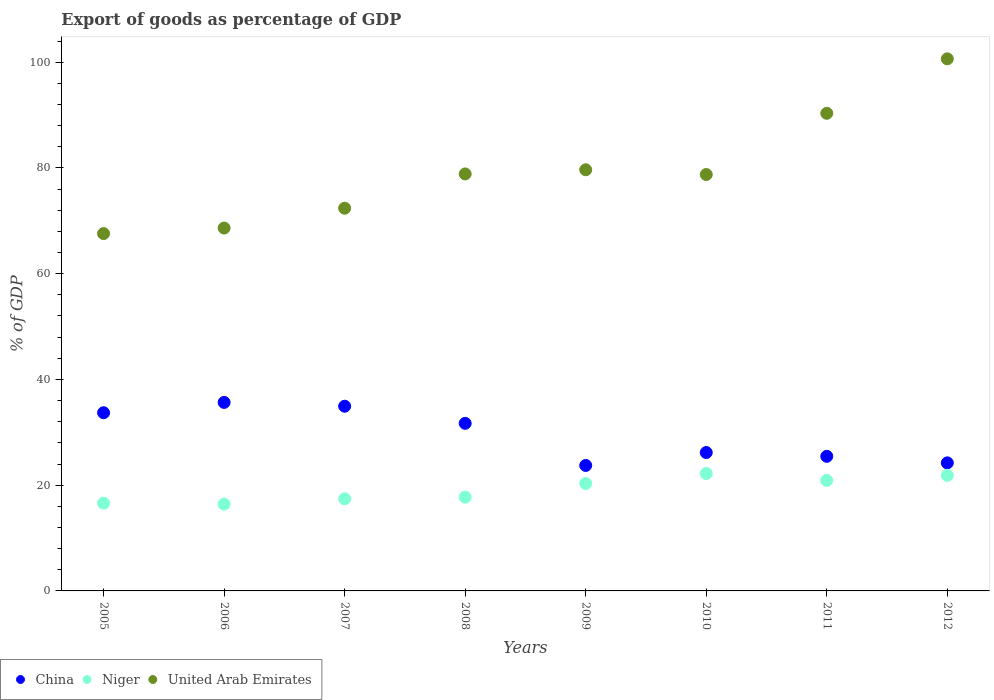What is the export of goods as percentage of GDP in United Arab Emirates in 2008?
Keep it short and to the point. 78.87. Across all years, what is the maximum export of goods as percentage of GDP in United Arab Emirates?
Make the answer very short. 100.63. Across all years, what is the minimum export of goods as percentage of GDP in China?
Make the answer very short. 23.73. What is the total export of goods as percentage of GDP in China in the graph?
Give a very brief answer. 235.56. What is the difference between the export of goods as percentage of GDP in China in 2005 and that in 2009?
Provide a short and direct response. 9.97. What is the difference between the export of goods as percentage of GDP in United Arab Emirates in 2005 and the export of goods as percentage of GDP in Niger in 2008?
Provide a short and direct response. 49.86. What is the average export of goods as percentage of GDP in United Arab Emirates per year?
Offer a very short reply. 79.61. In the year 2005, what is the difference between the export of goods as percentage of GDP in United Arab Emirates and export of goods as percentage of GDP in Niger?
Provide a succinct answer. 50.99. What is the ratio of the export of goods as percentage of GDP in United Arab Emirates in 2007 to that in 2010?
Give a very brief answer. 0.92. Is the export of goods as percentage of GDP in United Arab Emirates in 2007 less than that in 2008?
Your answer should be very brief. Yes. What is the difference between the highest and the second highest export of goods as percentage of GDP in United Arab Emirates?
Make the answer very short. 10.3. What is the difference between the highest and the lowest export of goods as percentage of GDP in United Arab Emirates?
Your response must be concise. 33.05. Is it the case that in every year, the sum of the export of goods as percentage of GDP in Niger and export of goods as percentage of GDP in China  is greater than the export of goods as percentage of GDP in United Arab Emirates?
Ensure brevity in your answer.  No. Does the export of goods as percentage of GDP in China monotonically increase over the years?
Give a very brief answer. No. How many years are there in the graph?
Provide a short and direct response. 8. Are the values on the major ticks of Y-axis written in scientific E-notation?
Give a very brief answer. No. Does the graph contain any zero values?
Provide a succinct answer. No. Does the graph contain grids?
Give a very brief answer. No. Where does the legend appear in the graph?
Provide a short and direct response. Bottom left. How are the legend labels stacked?
Your response must be concise. Horizontal. What is the title of the graph?
Ensure brevity in your answer.  Export of goods as percentage of GDP. Does "Congo (Democratic)" appear as one of the legend labels in the graph?
Offer a terse response. No. What is the label or title of the Y-axis?
Ensure brevity in your answer.  % of GDP. What is the % of GDP in China in 2005?
Provide a succinct answer. 33.7. What is the % of GDP in Niger in 2005?
Offer a very short reply. 16.6. What is the % of GDP of United Arab Emirates in 2005?
Provide a short and direct response. 67.59. What is the % of GDP of China in 2006?
Your answer should be compact. 35.65. What is the % of GDP of Niger in 2006?
Your answer should be very brief. 16.41. What is the % of GDP of United Arab Emirates in 2006?
Keep it short and to the point. 68.63. What is the % of GDP of China in 2007?
Ensure brevity in your answer.  34.93. What is the % of GDP of Niger in 2007?
Offer a very short reply. 17.43. What is the % of GDP in United Arab Emirates in 2007?
Keep it short and to the point. 72.38. What is the % of GDP in China in 2008?
Keep it short and to the point. 31.7. What is the % of GDP in Niger in 2008?
Give a very brief answer. 17.73. What is the % of GDP in United Arab Emirates in 2008?
Give a very brief answer. 78.87. What is the % of GDP of China in 2009?
Make the answer very short. 23.73. What is the % of GDP of Niger in 2009?
Ensure brevity in your answer.  20.32. What is the % of GDP of United Arab Emirates in 2009?
Offer a terse response. 79.65. What is the % of GDP of China in 2010?
Offer a terse response. 26.17. What is the % of GDP in Niger in 2010?
Make the answer very short. 22.2. What is the % of GDP in United Arab Emirates in 2010?
Offer a very short reply. 78.75. What is the % of GDP in China in 2011?
Offer a very short reply. 25.46. What is the % of GDP in Niger in 2011?
Give a very brief answer. 20.9. What is the % of GDP of United Arab Emirates in 2011?
Make the answer very short. 90.33. What is the % of GDP of China in 2012?
Make the answer very short. 24.22. What is the % of GDP of Niger in 2012?
Keep it short and to the point. 21.86. What is the % of GDP of United Arab Emirates in 2012?
Make the answer very short. 100.63. Across all years, what is the maximum % of GDP of China?
Your answer should be very brief. 35.65. Across all years, what is the maximum % of GDP of Niger?
Your response must be concise. 22.2. Across all years, what is the maximum % of GDP of United Arab Emirates?
Provide a short and direct response. 100.63. Across all years, what is the minimum % of GDP in China?
Ensure brevity in your answer.  23.73. Across all years, what is the minimum % of GDP in Niger?
Your answer should be compact. 16.41. Across all years, what is the minimum % of GDP of United Arab Emirates?
Offer a terse response. 67.59. What is the total % of GDP of China in the graph?
Your response must be concise. 235.56. What is the total % of GDP of Niger in the graph?
Offer a terse response. 153.45. What is the total % of GDP in United Arab Emirates in the graph?
Provide a succinct answer. 636.84. What is the difference between the % of GDP of China in 2005 and that in 2006?
Keep it short and to the point. -1.95. What is the difference between the % of GDP of Niger in 2005 and that in 2006?
Provide a short and direct response. 0.18. What is the difference between the % of GDP in United Arab Emirates in 2005 and that in 2006?
Provide a short and direct response. -1.05. What is the difference between the % of GDP in China in 2005 and that in 2007?
Provide a short and direct response. -1.23. What is the difference between the % of GDP in Niger in 2005 and that in 2007?
Your response must be concise. -0.83. What is the difference between the % of GDP in United Arab Emirates in 2005 and that in 2007?
Your answer should be compact. -4.8. What is the difference between the % of GDP of China in 2005 and that in 2008?
Offer a very short reply. 2.01. What is the difference between the % of GDP in Niger in 2005 and that in 2008?
Provide a short and direct response. -1.13. What is the difference between the % of GDP of United Arab Emirates in 2005 and that in 2008?
Give a very brief answer. -11.28. What is the difference between the % of GDP of China in 2005 and that in 2009?
Your answer should be very brief. 9.97. What is the difference between the % of GDP of Niger in 2005 and that in 2009?
Provide a succinct answer. -3.73. What is the difference between the % of GDP in United Arab Emirates in 2005 and that in 2009?
Make the answer very short. -12.07. What is the difference between the % of GDP of China in 2005 and that in 2010?
Offer a very short reply. 7.53. What is the difference between the % of GDP in Niger in 2005 and that in 2010?
Provide a succinct answer. -5.6. What is the difference between the % of GDP in United Arab Emirates in 2005 and that in 2010?
Your answer should be compact. -11.17. What is the difference between the % of GDP in China in 2005 and that in 2011?
Your answer should be very brief. 8.24. What is the difference between the % of GDP in Niger in 2005 and that in 2011?
Provide a short and direct response. -4.31. What is the difference between the % of GDP of United Arab Emirates in 2005 and that in 2011?
Offer a very short reply. -22.75. What is the difference between the % of GDP of China in 2005 and that in 2012?
Give a very brief answer. 9.48. What is the difference between the % of GDP of Niger in 2005 and that in 2012?
Ensure brevity in your answer.  -5.26. What is the difference between the % of GDP of United Arab Emirates in 2005 and that in 2012?
Provide a succinct answer. -33.05. What is the difference between the % of GDP of China in 2006 and that in 2007?
Your answer should be compact. 0.72. What is the difference between the % of GDP of Niger in 2006 and that in 2007?
Your answer should be very brief. -1.02. What is the difference between the % of GDP in United Arab Emirates in 2006 and that in 2007?
Ensure brevity in your answer.  -3.75. What is the difference between the % of GDP of China in 2006 and that in 2008?
Give a very brief answer. 3.96. What is the difference between the % of GDP of Niger in 2006 and that in 2008?
Make the answer very short. -1.32. What is the difference between the % of GDP in United Arab Emirates in 2006 and that in 2008?
Offer a very short reply. -10.24. What is the difference between the % of GDP of China in 2006 and that in 2009?
Offer a terse response. 11.92. What is the difference between the % of GDP in Niger in 2006 and that in 2009?
Provide a succinct answer. -3.91. What is the difference between the % of GDP of United Arab Emirates in 2006 and that in 2009?
Your response must be concise. -11.02. What is the difference between the % of GDP in China in 2006 and that in 2010?
Offer a very short reply. 9.48. What is the difference between the % of GDP of Niger in 2006 and that in 2010?
Ensure brevity in your answer.  -5.79. What is the difference between the % of GDP in United Arab Emirates in 2006 and that in 2010?
Provide a short and direct response. -10.12. What is the difference between the % of GDP in China in 2006 and that in 2011?
Your response must be concise. 10.2. What is the difference between the % of GDP in Niger in 2006 and that in 2011?
Your response must be concise. -4.49. What is the difference between the % of GDP of United Arab Emirates in 2006 and that in 2011?
Give a very brief answer. -21.7. What is the difference between the % of GDP in China in 2006 and that in 2012?
Keep it short and to the point. 11.43. What is the difference between the % of GDP in Niger in 2006 and that in 2012?
Provide a succinct answer. -5.45. What is the difference between the % of GDP in United Arab Emirates in 2006 and that in 2012?
Your response must be concise. -32. What is the difference between the % of GDP of China in 2007 and that in 2008?
Your response must be concise. 3.24. What is the difference between the % of GDP of Niger in 2007 and that in 2008?
Your answer should be very brief. -0.3. What is the difference between the % of GDP of United Arab Emirates in 2007 and that in 2008?
Offer a very short reply. -6.48. What is the difference between the % of GDP in China in 2007 and that in 2009?
Make the answer very short. 11.2. What is the difference between the % of GDP in Niger in 2007 and that in 2009?
Your response must be concise. -2.89. What is the difference between the % of GDP in United Arab Emirates in 2007 and that in 2009?
Your response must be concise. -7.27. What is the difference between the % of GDP in China in 2007 and that in 2010?
Make the answer very short. 8.76. What is the difference between the % of GDP of Niger in 2007 and that in 2010?
Your answer should be compact. -4.77. What is the difference between the % of GDP of United Arab Emirates in 2007 and that in 2010?
Provide a succinct answer. -6.37. What is the difference between the % of GDP in China in 2007 and that in 2011?
Keep it short and to the point. 9.48. What is the difference between the % of GDP of Niger in 2007 and that in 2011?
Keep it short and to the point. -3.47. What is the difference between the % of GDP of United Arab Emirates in 2007 and that in 2011?
Provide a succinct answer. -17.95. What is the difference between the % of GDP of China in 2007 and that in 2012?
Your answer should be compact. 10.71. What is the difference between the % of GDP in Niger in 2007 and that in 2012?
Your response must be concise. -4.43. What is the difference between the % of GDP in United Arab Emirates in 2007 and that in 2012?
Provide a succinct answer. -28.25. What is the difference between the % of GDP in China in 2008 and that in 2009?
Provide a short and direct response. 7.96. What is the difference between the % of GDP in Niger in 2008 and that in 2009?
Provide a short and direct response. -2.59. What is the difference between the % of GDP of United Arab Emirates in 2008 and that in 2009?
Your response must be concise. -0.79. What is the difference between the % of GDP in China in 2008 and that in 2010?
Keep it short and to the point. 5.52. What is the difference between the % of GDP of Niger in 2008 and that in 2010?
Offer a very short reply. -4.47. What is the difference between the % of GDP in United Arab Emirates in 2008 and that in 2010?
Your answer should be very brief. 0.11. What is the difference between the % of GDP in China in 2008 and that in 2011?
Your response must be concise. 6.24. What is the difference between the % of GDP in Niger in 2008 and that in 2011?
Keep it short and to the point. -3.17. What is the difference between the % of GDP of United Arab Emirates in 2008 and that in 2011?
Offer a terse response. -11.47. What is the difference between the % of GDP in China in 2008 and that in 2012?
Give a very brief answer. 7.48. What is the difference between the % of GDP of Niger in 2008 and that in 2012?
Your response must be concise. -4.13. What is the difference between the % of GDP of United Arab Emirates in 2008 and that in 2012?
Ensure brevity in your answer.  -21.77. What is the difference between the % of GDP in China in 2009 and that in 2010?
Your response must be concise. -2.44. What is the difference between the % of GDP of Niger in 2009 and that in 2010?
Give a very brief answer. -1.88. What is the difference between the % of GDP in United Arab Emirates in 2009 and that in 2010?
Give a very brief answer. 0.9. What is the difference between the % of GDP in China in 2009 and that in 2011?
Provide a short and direct response. -1.72. What is the difference between the % of GDP of Niger in 2009 and that in 2011?
Ensure brevity in your answer.  -0.58. What is the difference between the % of GDP of United Arab Emirates in 2009 and that in 2011?
Make the answer very short. -10.68. What is the difference between the % of GDP in China in 2009 and that in 2012?
Keep it short and to the point. -0.49. What is the difference between the % of GDP of Niger in 2009 and that in 2012?
Provide a short and direct response. -1.54. What is the difference between the % of GDP of United Arab Emirates in 2009 and that in 2012?
Your response must be concise. -20.98. What is the difference between the % of GDP in China in 2010 and that in 2011?
Provide a short and direct response. 0.72. What is the difference between the % of GDP in Niger in 2010 and that in 2011?
Provide a short and direct response. 1.3. What is the difference between the % of GDP of United Arab Emirates in 2010 and that in 2011?
Keep it short and to the point. -11.58. What is the difference between the % of GDP in China in 2010 and that in 2012?
Offer a terse response. 1.95. What is the difference between the % of GDP in Niger in 2010 and that in 2012?
Your answer should be compact. 0.34. What is the difference between the % of GDP in United Arab Emirates in 2010 and that in 2012?
Make the answer very short. -21.88. What is the difference between the % of GDP in China in 2011 and that in 2012?
Your response must be concise. 1.24. What is the difference between the % of GDP in Niger in 2011 and that in 2012?
Your response must be concise. -0.96. What is the difference between the % of GDP of United Arab Emirates in 2011 and that in 2012?
Offer a very short reply. -10.3. What is the difference between the % of GDP in China in 2005 and the % of GDP in Niger in 2006?
Keep it short and to the point. 17.29. What is the difference between the % of GDP in China in 2005 and the % of GDP in United Arab Emirates in 2006?
Provide a succinct answer. -34.93. What is the difference between the % of GDP of Niger in 2005 and the % of GDP of United Arab Emirates in 2006?
Provide a succinct answer. -52.04. What is the difference between the % of GDP of China in 2005 and the % of GDP of Niger in 2007?
Provide a short and direct response. 16.27. What is the difference between the % of GDP of China in 2005 and the % of GDP of United Arab Emirates in 2007?
Your response must be concise. -38.68. What is the difference between the % of GDP in Niger in 2005 and the % of GDP in United Arab Emirates in 2007?
Your response must be concise. -55.79. What is the difference between the % of GDP of China in 2005 and the % of GDP of Niger in 2008?
Provide a succinct answer. 15.97. What is the difference between the % of GDP in China in 2005 and the % of GDP in United Arab Emirates in 2008?
Provide a succinct answer. -45.17. What is the difference between the % of GDP of Niger in 2005 and the % of GDP of United Arab Emirates in 2008?
Keep it short and to the point. -62.27. What is the difference between the % of GDP of China in 2005 and the % of GDP of Niger in 2009?
Your answer should be compact. 13.38. What is the difference between the % of GDP of China in 2005 and the % of GDP of United Arab Emirates in 2009?
Keep it short and to the point. -45.95. What is the difference between the % of GDP in Niger in 2005 and the % of GDP in United Arab Emirates in 2009?
Offer a very short reply. -63.06. What is the difference between the % of GDP of China in 2005 and the % of GDP of Niger in 2010?
Provide a succinct answer. 11.5. What is the difference between the % of GDP of China in 2005 and the % of GDP of United Arab Emirates in 2010?
Offer a terse response. -45.05. What is the difference between the % of GDP in Niger in 2005 and the % of GDP in United Arab Emirates in 2010?
Your answer should be compact. -62.16. What is the difference between the % of GDP in China in 2005 and the % of GDP in Niger in 2011?
Give a very brief answer. 12.8. What is the difference between the % of GDP of China in 2005 and the % of GDP of United Arab Emirates in 2011?
Keep it short and to the point. -56.63. What is the difference between the % of GDP in Niger in 2005 and the % of GDP in United Arab Emirates in 2011?
Provide a succinct answer. -73.74. What is the difference between the % of GDP of China in 2005 and the % of GDP of Niger in 2012?
Offer a terse response. 11.84. What is the difference between the % of GDP in China in 2005 and the % of GDP in United Arab Emirates in 2012?
Offer a terse response. -66.93. What is the difference between the % of GDP of Niger in 2005 and the % of GDP of United Arab Emirates in 2012?
Offer a terse response. -84.04. What is the difference between the % of GDP in China in 2006 and the % of GDP in Niger in 2007?
Offer a terse response. 18.22. What is the difference between the % of GDP in China in 2006 and the % of GDP in United Arab Emirates in 2007?
Your response must be concise. -36.73. What is the difference between the % of GDP in Niger in 2006 and the % of GDP in United Arab Emirates in 2007?
Your answer should be very brief. -55.97. What is the difference between the % of GDP of China in 2006 and the % of GDP of Niger in 2008?
Provide a succinct answer. 17.92. What is the difference between the % of GDP in China in 2006 and the % of GDP in United Arab Emirates in 2008?
Your answer should be very brief. -43.22. What is the difference between the % of GDP of Niger in 2006 and the % of GDP of United Arab Emirates in 2008?
Offer a terse response. -62.46. What is the difference between the % of GDP in China in 2006 and the % of GDP in Niger in 2009?
Provide a succinct answer. 15.33. What is the difference between the % of GDP of China in 2006 and the % of GDP of United Arab Emirates in 2009?
Your answer should be compact. -44. What is the difference between the % of GDP in Niger in 2006 and the % of GDP in United Arab Emirates in 2009?
Your answer should be very brief. -63.24. What is the difference between the % of GDP of China in 2006 and the % of GDP of Niger in 2010?
Provide a succinct answer. 13.45. What is the difference between the % of GDP of China in 2006 and the % of GDP of United Arab Emirates in 2010?
Provide a succinct answer. -43.1. What is the difference between the % of GDP in Niger in 2006 and the % of GDP in United Arab Emirates in 2010?
Your answer should be compact. -62.34. What is the difference between the % of GDP in China in 2006 and the % of GDP in Niger in 2011?
Offer a terse response. 14.75. What is the difference between the % of GDP in China in 2006 and the % of GDP in United Arab Emirates in 2011?
Keep it short and to the point. -54.68. What is the difference between the % of GDP in Niger in 2006 and the % of GDP in United Arab Emirates in 2011?
Ensure brevity in your answer.  -73.92. What is the difference between the % of GDP of China in 2006 and the % of GDP of Niger in 2012?
Offer a very short reply. 13.79. What is the difference between the % of GDP of China in 2006 and the % of GDP of United Arab Emirates in 2012?
Ensure brevity in your answer.  -64.98. What is the difference between the % of GDP in Niger in 2006 and the % of GDP in United Arab Emirates in 2012?
Keep it short and to the point. -84.22. What is the difference between the % of GDP of China in 2007 and the % of GDP of Niger in 2008?
Offer a very short reply. 17.2. What is the difference between the % of GDP of China in 2007 and the % of GDP of United Arab Emirates in 2008?
Make the answer very short. -43.94. What is the difference between the % of GDP in Niger in 2007 and the % of GDP in United Arab Emirates in 2008?
Provide a succinct answer. -61.44. What is the difference between the % of GDP of China in 2007 and the % of GDP of Niger in 2009?
Offer a terse response. 14.61. What is the difference between the % of GDP in China in 2007 and the % of GDP in United Arab Emirates in 2009?
Ensure brevity in your answer.  -44.72. What is the difference between the % of GDP in Niger in 2007 and the % of GDP in United Arab Emirates in 2009?
Ensure brevity in your answer.  -62.22. What is the difference between the % of GDP in China in 2007 and the % of GDP in Niger in 2010?
Your answer should be compact. 12.73. What is the difference between the % of GDP of China in 2007 and the % of GDP of United Arab Emirates in 2010?
Provide a succinct answer. -43.82. What is the difference between the % of GDP in Niger in 2007 and the % of GDP in United Arab Emirates in 2010?
Ensure brevity in your answer.  -61.33. What is the difference between the % of GDP in China in 2007 and the % of GDP in Niger in 2011?
Your answer should be compact. 14.03. What is the difference between the % of GDP of China in 2007 and the % of GDP of United Arab Emirates in 2011?
Your answer should be very brief. -55.4. What is the difference between the % of GDP of Niger in 2007 and the % of GDP of United Arab Emirates in 2011?
Keep it short and to the point. -72.9. What is the difference between the % of GDP in China in 2007 and the % of GDP in Niger in 2012?
Give a very brief answer. 13.07. What is the difference between the % of GDP in China in 2007 and the % of GDP in United Arab Emirates in 2012?
Offer a terse response. -65.7. What is the difference between the % of GDP in Niger in 2007 and the % of GDP in United Arab Emirates in 2012?
Provide a short and direct response. -83.21. What is the difference between the % of GDP of China in 2008 and the % of GDP of Niger in 2009?
Your response must be concise. 11.37. What is the difference between the % of GDP in China in 2008 and the % of GDP in United Arab Emirates in 2009?
Your answer should be very brief. -47.96. What is the difference between the % of GDP of Niger in 2008 and the % of GDP of United Arab Emirates in 2009?
Offer a terse response. -61.92. What is the difference between the % of GDP in China in 2008 and the % of GDP in Niger in 2010?
Offer a terse response. 9.5. What is the difference between the % of GDP of China in 2008 and the % of GDP of United Arab Emirates in 2010?
Keep it short and to the point. -47.06. What is the difference between the % of GDP of Niger in 2008 and the % of GDP of United Arab Emirates in 2010?
Offer a terse response. -61.02. What is the difference between the % of GDP in China in 2008 and the % of GDP in Niger in 2011?
Your answer should be compact. 10.79. What is the difference between the % of GDP of China in 2008 and the % of GDP of United Arab Emirates in 2011?
Make the answer very short. -58.64. What is the difference between the % of GDP in Niger in 2008 and the % of GDP in United Arab Emirates in 2011?
Offer a terse response. -72.6. What is the difference between the % of GDP in China in 2008 and the % of GDP in Niger in 2012?
Keep it short and to the point. 9.84. What is the difference between the % of GDP in China in 2008 and the % of GDP in United Arab Emirates in 2012?
Provide a short and direct response. -68.94. What is the difference between the % of GDP in Niger in 2008 and the % of GDP in United Arab Emirates in 2012?
Your answer should be very brief. -82.9. What is the difference between the % of GDP of China in 2009 and the % of GDP of Niger in 2010?
Provide a succinct answer. 1.54. What is the difference between the % of GDP of China in 2009 and the % of GDP of United Arab Emirates in 2010?
Provide a short and direct response. -55.02. What is the difference between the % of GDP of Niger in 2009 and the % of GDP of United Arab Emirates in 2010?
Your response must be concise. -58.43. What is the difference between the % of GDP of China in 2009 and the % of GDP of Niger in 2011?
Provide a succinct answer. 2.83. What is the difference between the % of GDP of China in 2009 and the % of GDP of United Arab Emirates in 2011?
Your response must be concise. -66.6. What is the difference between the % of GDP of Niger in 2009 and the % of GDP of United Arab Emirates in 2011?
Offer a very short reply. -70.01. What is the difference between the % of GDP in China in 2009 and the % of GDP in Niger in 2012?
Provide a short and direct response. 1.87. What is the difference between the % of GDP of China in 2009 and the % of GDP of United Arab Emirates in 2012?
Provide a succinct answer. -76.9. What is the difference between the % of GDP of Niger in 2009 and the % of GDP of United Arab Emirates in 2012?
Your answer should be compact. -80.31. What is the difference between the % of GDP of China in 2010 and the % of GDP of Niger in 2011?
Offer a terse response. 5.27. What is the difference between the % of GDP in China in 2010 and the % of GDP in United Arab Emirates in 2011?
Your answer should be very brief. -64.16. What is the difference between the % of GDP of Niger in 2010 and the % of GDP of United Arab Emirates in 2011?
Ensure brevity in your answer.  -68.13. What is the difference between the % of GDP in China in 2010 and the % of GDP in Niger in 2012?
Give a very brief answer. 4.31. What is the difference between the % of GDP in China in 2010 and the % of GDP in United Arab Emirates in 2012?
Give a very brief answer. -74.46. What is the difference between the % of GDP of Niger in 2010 and the % of GDP of United Arab Emirates in 2012?
Offer a very short reply. -78.44. What is the difference between the % of GDP of China in 2011 and the % of GDP of Niger in 2012?
Ensure brevity in your answer.  3.6. What is the difference between the % of GDP in China in 2011 and the % of GDP in United Arab Emirates in 2012?
Make the answer very short. -75.18. What is the difference between the % of GDP of Niger in 2011 and the % of GDP of United Arab Emirates in 2012?
Your answer should be compact. -79.73. What is the average % of GDP of China per year?
Offer a terse response. 29.45. What is the average % of GDP of Niger per year?
Keep it short and to the point. 19.18. What is the average % of GDP in United Arab Emirates per year?
Provide a short and direct response. 79.61. In the year 2005, what is the difference between the % of GDP of China and % of GDP of Niger?
Offer a very short reply. 17.11. In the year 2005, what is the difference between the % of GDP in China and % of GDP in United Arab Emirates?
Ensure brevity in your answer.  -33.88. In the year 2005, what is the difference between the % of GDP of Niger and % of GDP of United Arab Emirates?
Make the answer very short. -50.99. In the year 2006, what is the difference between the % of GDP of China and % of GDP of Niger?
Offer a very short reply. 19.24. In the year 2006, what is the difference between the % of GDP in China and % of GDP in United Arab Emirates?
Your answer should be compact. -32.98. In the year 2006, what is the difference between the % of GDP of Niger and % of GDP of United Arab Emirates?
Your answer should be very brief. -52.22. In the year 2007, what is the difference between the % of GDP in China and % of GDP in Niger?
Your answer should be very brief. 17.5. In the year 2007, what is the difference between the % of GDP of China and % of GDP of United Arab Emirates?
Ensure brevity in your answer.  -37.45. In the year 2007, what is the difference between the % of GDP of Niger and % of GDP of United Arab Emirates?
Provide a succinct answer. -54.96. In the year 2008, what is the difference between the % of GDP of China and % of GDP of Niger?
Provide a short and direct response. 13.96. In the year 2008, what is the difference between the % of GDP of China and % of GDP of United Arab Emirates?
Make the answer very short. -47.17. In the year 2008, what is the difference between the % of GDP of Niger and % of GDP of United Arab Emirates?
Your response must be concise. -61.14. In the year 2009, what is the difference between the % of GDP of China and % of GDP of Niger?
Your response must be concise. 3.41. In the year 2009, what is the difference between the % of GDP in China and % of GDP in United Arab Emirates?
Provide a short and direct response. -55.92. In the year 2009, what is the difference between the % of GDP of Niger and % of GDP of United Arab Emirates?
Provide a succinct answer. -59.33. In the year 2010, what is the difference between the % of GDP in China and % of GDP in Niger?
Offer a very short reply. 3.97. In the year 2010, what is the difference between the % of GDP of China and % of GDP of United Arab Emirates?
Provide a short and direct response. -52.58. In the year 2010, what is the difference between the % of GDP of Niger and % of GDP of United Arab Emirates?
Your response must be concise. -56.56. In the year 2011, what is the difference between the % of GDP of China and % of GDP of Niger?
Provide a short and direct response. 4.55. In the year 2011, what is the difference between the % of GDP in China and % of GDP in United Arab Emirates?
Provide a short and direct response. -64.88. In the year 2011, what is the difference between the % of GDP in Niger and % of GDP in United Arab Emirates?
Your response must be concise. -69.43. In the year 2012, what is the difference between the % of GDP in China and % of GDP in Niger?
Your answer should be compact. 2.36. In the year 2012, what is the difference between the % of GDP of China and % of GDP of United Arab Emirates?
Keep it short and to the point. -76.42. In the year 2012, what is the difference between the % of GDP of Niger and % of GDP of United Arab Emirates?
Offer a very short reply. -78.78. What is the ratio of the % of GDP of China in 2005 to that in 2006?
Offer a terse response. 0.95. What is the ratio of the % of GDP of Niger in 2005 to that in 2006?
Give a very brief answer. 1.01. What is the ratio of the % of GDP of United Arab Emirates in 2005 to that in 2006?
Offer a very short reply. 0.98. What is the ratio of the % of GDP of China in 2005 to that in 2007?
Offer a very short reply. 0.96. What is the ratio of the % of GDP in Niger in 2005 to that in 2007?
Provide a short and direct response. 0.95. What is the ratio of the % of GDP in United Arab Emirates in 2005 to that in 2007?
Provide a short and direct response. 0.93. What is the ratio of the % of GDP in China in 2005 to that in 2008?
Offer a terse response. 1.06. What is the ratio of the % of GDP in Niger in 2005 to that in 2008?
Your response must be concise. 0.94. What is the ratio of the % of GDP of United Arab Emirates in 2005 to that in 2008?
Offer a very short reply. 0.86. What is the ratio of the % of GDP in China in 2005 to that in 2009?
Make the answer very short. 1.42. What is the ratio of the % of GDP in Niger in 2005 to that in 2009?
Your answer should be compact. 0.82. What is the ratio of the % of GDP in United Arab Emirates in 2005 to that in 2009?
Provide a short and direct response. 0.85. What is the ratio of the % of GDP in China in 2005 to that in 2010?
Give a very brief answer. 1.29. What is the ratio of the % of GDP of Niger in 2005 to that in 2010?
Keep it short and to the point. 0.75. What is the ratio of the % of GDP in United Arab Emirates in 2005 to that in 2010?
Your response must be concise. 0.86. What is the ratio of the % of GDP in China in 2005 to that in 2011?
Ensure brevity in your answer.  1.32. What is the ratio of the % of GDP of Niger in 2005 to that in 2011?
Make the answer very short. 0.79. What is the ratio of the % of GDP in United Arab Emirates in 2005 to that in 2011?
Offer a very short reply. 0.75. What is the ratio of the % of GDP in China in 2005 to that in 2012?
Offer a very short reply. 1.39. What is the ratio of the % of GDP of Niger in 2005 to that in 2012?
Offer a very short reply. 0.76. What is the ratio of the % of GDP in United Arab Emirates in 2005 to that in 2012?
Your answer should be very brief. 0.67. What is the ratio of the % of GDP of China in 2006 to that in 2007?
Ensure brevity in your answer.  1.02. What is the ratio of the % of GDP in Niger in 2006 to that in 2007?
Ensure brevity in your answer.  0.94. What is the ratio of the % of GDP of United Arab Emirates in 2006 to that in 2007?
Your answer should be compact. 0.95. What is the ratio of the % of GDP in China in 2006 to that in 2008?
Offer a terse response. 1.12. What is the ratio of the % of GDP in Niger in 2006 to that in 2008?
Keep it short and to the point. 0.93. What is the ratio of the % of GDP in United Arab Emirates in 2006 to that in 2008?
Your answer should be very brief. 0.87. What is the ratio of the % of GDP in China in 2006 to that in 2009?
Your answer should be very brief. 1.5. What is the ratio of the % of GDP of Niger in 2006 to that in 2009?
Give a very brief answer. 0.81. What is the ratio of the % of GDP in United Arab Emirates in 2006 to that in 2009?
Offer a terse response. 0.86. What is the ratio of the % of GDP of China in 2006 to that in 2010?
Ensure brevity in your answer.  1.36. What is the ratio of the % of GDP in Niger in 2006 to that in 2010?
Ensure brevity in your answer.  0.74. What is the ratio of the % of GDP in United Arab Emirates in 2006 to that in 2010?
Your answer should be compact. 0.87. What is the ratio of the % of GDP of China in 2006 to that in 2011?
Provide a short and direct response. 1.4. What is the ratio of the % of GDP of Niger in 2006 to that in 2011?
Your answer should be very brief. 0.79. What is the ratio of the % of GDP of United Arab Emirates in 2006 to that in 2011?
Provide a short and direct response. 0.76. What is the ratio of the % of GDP of China in 2006 to that in 2012?
Keep it short and to the point. 1.47. What is the ratio of the % of GDP in Niger in 2006 to that in 2012?
Offer a very short reply. 0.75. What is the ratio of the % of GDP of United Arab Emirates in 2006 to that in 2012?
Ensure brevity in your answer.  0.68. What is the ratio of the % of GDP in China in 2007 to that in 2008?
Provide a succinct answer. 1.1. What is the ratio of the % of GDP of Niger in 2007 to that in 2008?
Your answer should be very brief. 0.98. What is the ratio of the % of GDP of United Arab Emirates in 2007 to that in 2008?
Make the answer very short. 0.92. What is the ratio of the % of GDP in China in 2007 to that in 2009?
Offer a very short reply. 1.47. What is the ratio of the % of GDP in Niger in 2007 to that in 2009?
Your answer should be compact. 0.86. What is the ratio of the % of GDP of United Arab Emirates in 2007 to that in 2009?
Offer a very short reply. 0.91. What is the ratio of the % of GDP of China in 2007 to that in 2010?
Your answer should be compact. 1.33. What is the ratio of the % of GDP in Niger in 2007 to that in 2010?
Offer a terse response. 0.79. What is the ratio of the % of GDP in United Arab Emirates in 2007 to that in 2010?
Offer a terse response. 0.92. What is the ratio of the % of GDP of China in 2007 to that in 2011?
Your answer should be very brief. 1.37. What is the ratio of the % of GDP of Niger in 2007 to that in 2011?
Provide a succinct answer. 0.83. What is the ratio of the % of GDP in United Arab Emirates in 2007 to that in 2011?
Keep it short and to the point. 0.8. What is the ratio of the % of GDP of China in 2007 to that in 2012?
Provide a succinct answer. 1.44. What is the ratio of the % of GDP of Niger in 2007 to that in 2012?
Make the answer very short. 0.8. What is the ratio of the % of GDP in United Arab Emirates in 2007 to that in 2012?
Give a very brief answer. 0.72. What is the ratio of the % of GDP of China in 2008 to that in 2009?
Provide a succinct answer. 1.34. What is the ratio of the % of GDP of Niger in 2008 to that in 2009?
Ensure brevity in your answer.  0.87. What is the ratio of the % of GDP of China in 2008 to that in 2010?
Your answer should be very brief. 1.21. What is the ratio of the % of GDP in Niger in 2008 to that in 2010?
Your response must be concise. 0.8. What is the ratio of the % of GDP in China in 2008 to that in 2011?
Make the answer very short. 1.25. What is the ratio of the % of GDP of Niger in 2008 to that in 2011?
Your answer should be compact. 0.85. What is the ratio of the % of GDP in United Arab Emirates in 2008 to that in 2011?
Give a very brief answer. 0.87. What is the ratio of the % of GDP of China in 2008 to that in 2012?
Your answer should be very brief. 1.31. What is the ratio of the % of GDP in Niger in 2008 to that in 2012?
Give a very brief answer. 0.81. What is the ratio of the % of GDP in United Arab Emirates in 2008 to that in 2012?
Your answer should be very brief. 0.78. What is the ratio of the % of GDP in China in 2009 to that in 2010?
Offer a terse response. 0.91. What is the ratio of the % of GDP in Niger in 2009 to that in 2010?
Your answer should be compact. 0.92. What is the ratio of the % of GDP of United Arab Emirates in 2009 to that in 2010?
Provide a succinct answer. 1.01. What is the ratio of the % of GDP of China in 2009 to that in 2011?
Keep it short and to the point. 0.93. What is the ratio of the % of GDP of Niger in 2009 to that in 2011?
Your answer should be very brief. 0.97. What is the ratio of the % of GDP of United Arab Emirates in 2009 to that in 2011?
Offer a very short reply. 0.88. What is the ratio of the % of GDP in Niger in 2009 to that in 2012?
Offer a very short reply. 0.93. What is the ratio of the % of GDP in United Arab Emirates in 2009 to that in 2012?
Make the answer very short. 0.79. What is the ratio of the % of GDP of China in 2010 to that in 2011?
Your response must be concise. 1.03. What is the ratio of the % of GDP in Niger in 2010 to that in 2011?
Your answer should be compact. 1.06. What is the ratio of the % of GDP of United Arab Emirates in 2010 to that in 2011?
Provide a short and direct response. 0.87. What is the ratio of the % of GDP of China in 2010 to that in 2012?
Give a very brief answer. 1.08. What is the ratio of the % of GDP of Niger in 2010 to that in 2012?
Ensure brevity in your answer.  1.02. What is the ratio of the % of GDP of United Arab Emirates in 2010 to that in 2012?
Your answer should be compact. 0.78. What is the ratio of the % of GDP of China in 2011 to that in 2012?
Ensure brevity in your answer.  1.05. What is the ratio of the % of GDP of Niger in 2011 to that in 2012?
Provide a succinct answer. 0.96. What is the ratio of the % of GDP in United Arab Emirates in 2011 to that in 2012?
Your answer should be compact. 0.9. What is the difference between the highest and the second highest % of GDP of China?
Offer a terse response. 0.72. What is the difference between the highest and the second highest % of GDP of Niger?
Ensure brevity in your answer.  0.34. What is the difference between the highest and the second highest % of GDP in United Arab Emirates?
Provide a succinct answer. 10.3. What is the difference between the highest and the lowest % of GDP of China?
Offer a terse response. 11.92. What is the difference between the highest and the lowest % of GDP of Niger?
Your response must be concise. 5.79. What is the difference between the highest and the lowest % of GDP of United Arab Emirates?
Your response must be concise. 33.05. 